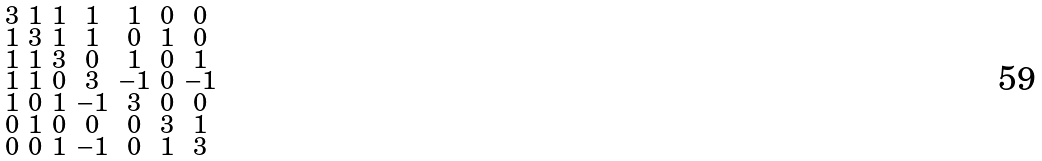Convert formula to latex. <formula><loc_0><loc_0><loc_500><loc_500>\begin{smallmatrix} 3 & 1 & 1 & 1 & 1 & 0 & 0 \\ 1 & 3 & 1 & 1 & 0 & 1 & 0 \\ 1 & 1 & 3 & 0 & 1 & 0 & 1 \\ 1 & 1 & 0 & 3 & - 1 & 0 & - 1 \\ 1 & 0 & 1 & - 1 & 3 & 0 & 0 \\ 0 & 1 & 0 & 0 & 0 & 3 & 1 \\ 0 & 0 & 1 & - 1 & 0 & 1 & 3 \end{smallmatrix}</formula> 